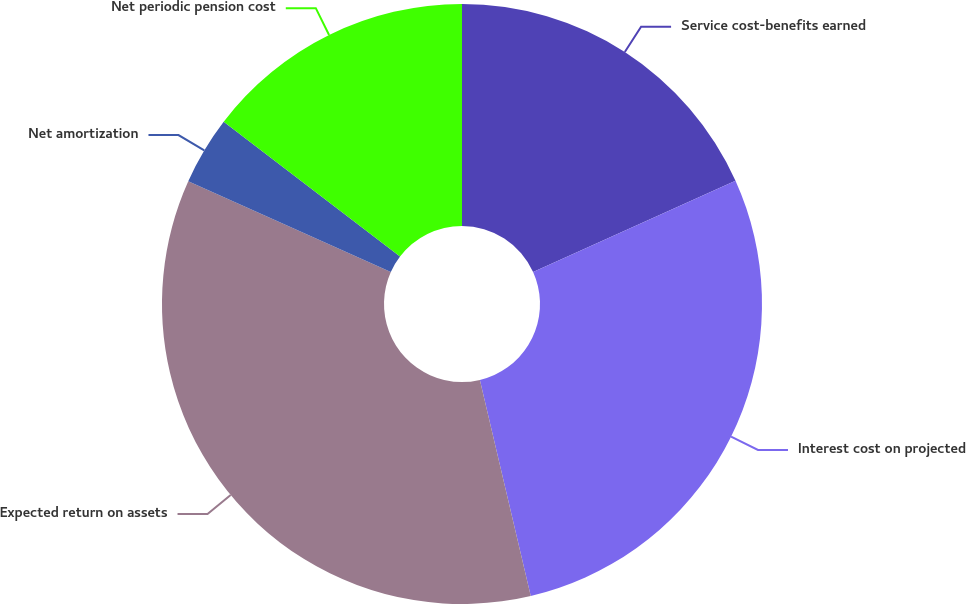<chart> <loc_0><loc_0><loc_500><loc_500><pie_chart><fcel>Service cost-benefits earned<fcel>Interest cost on projected<fcel>Expected return on assets<fcel>Net amortization<fcel>Net periodic pension cost<nl><fcel>18.26%<fcel>28.06%<fcel>35.39%<fcel>3.68%<fcel>14.61%<nl></chart> 